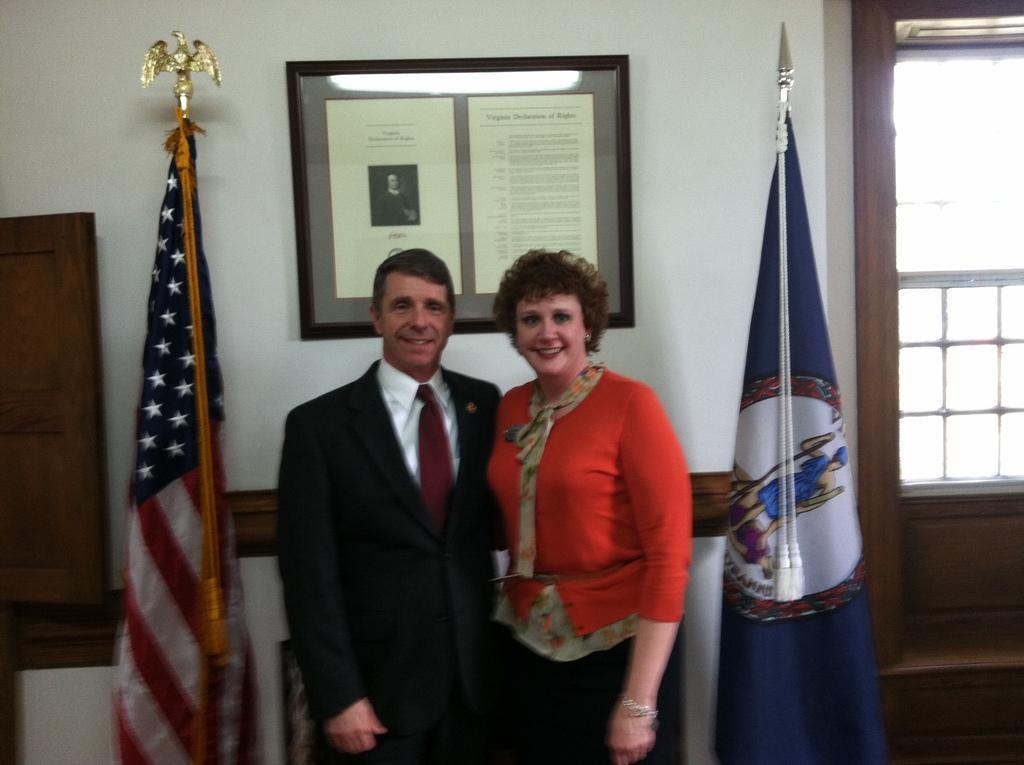Please provide a concise description of this image. In this image I can see 2 people standing in the center. The person standing on the left is wearing a suit. There are 2 flags on their either sides. There is a photo frame on the wall and a window on the right. 